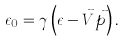<formula> <loc_0><loc_0><loc_500><loc_500>\epsilon _ { 0 } = \gamma \left ( \epsilon - \vec { V } \vec { p } \right ) .</formula> 